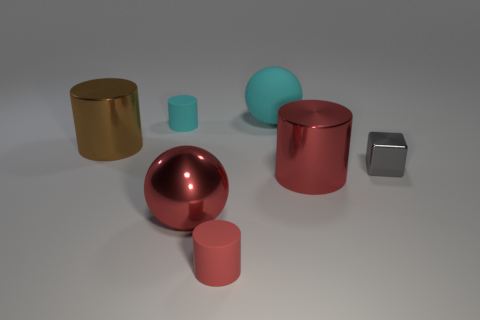Is the number of cyan spheres that are to the left of the small red cylinder less than the number of red metal cylinders that are left of the small cyan matte object?
Give a very brief answer. No. How many objects are either big red objects or tiny gray shiny cubes?
Your answer should be very brief. 3. What number of matte things are behind the tiny cyan cylinder?
Keep it short and to the point. 1. What is the shape of the other cyan object that is made of the same material as the large cyan thing?
Offer a very short reply. Cylinder. Is the shape of the large red shiny object to the left of the red rubber cylinder the same as  the big matte object?
Your response must be concise. Yes. How many brown objects are either tiny cylinders or shiny things?
Your answer should be very brief. 1. Are there an equal number of tiny metal things that are in front of the big red metal ball and small gray things to the left of the brown thing?
Keep it short and to the point. Yes. What is the color of the big ball behind the tiny rubber cylinder that is behind the large metallic cylinder that is in front of the big brown shiny cylinder?
Your answer should be very brief. Cyan. Are there any other things of the same color as the tiny shiny block?
Make the answer very short. No. There is a thing that is the same color as the big matte ball; what shape is it?
Ensure brevity in your answer.  Cylinder. 